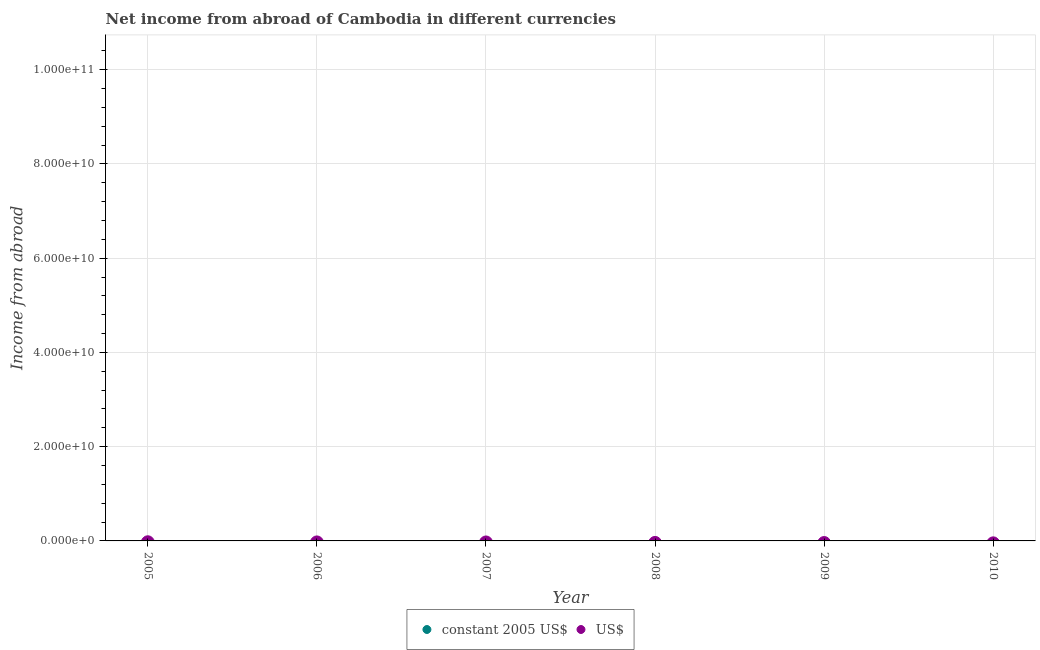How many different coloured dotlines are there?
Make the answer very short. 0. Is the number of dotlines equal to the number of legend labels?
Your answer should be compact. No. What is the total income from abroad in constant 2005 us$ in the graph?
Offer a very short reply. 0. What is the average income from abroad in us$ per year?
Your answer should be very brief. 0. Does the income from abroad in us$ monotonically increase over the years?
Provide a short and direct response. No. Is the income from abroad in us$ strictly greater than the income from abroad in constant 2005 us$ over the years?
Provide a short and direct response. Yes. Is the income from abroad in constant 2005 us$ strictly less than the income from abroad in us$ over the years?
Keep it short and to the point. Yes. How many dotlines are there?
Keep it short and to the point. 0. How many years are there in the graph?
Offer a very short reply. 6. What is the difference between two consecutive major ticks on the Y-axis?
Keep it short and to the point. 2.00e+1. Are the values on the major ticks of Y-axis written in scientific E-notation?
Ensure brevity in your answer.  Yes. Does the graph contain any zero values?
Your answer should be very brief. Yes. Where does the legend appear in the graph?
Ensure brevity in your answer.  Bottom center. How many legend labels are there?
Make the answer very short. 2. How are the legend labels stacked?
Your answer should be very brief. Horizontal. What is the title of the graph?
Offer a very short reply. Net income from abroad of Cambodia in different currencies. Does "Registered firms" appear as one of the legend labels in the graph?
Keep it short and to the point. No. What is the label or title of the X-axis?
Keep it short and to the point. Year. What is the label or title of the Y-axis?
Your answer should be compact. Income from abroad. What is the Income from abroad in constant 2005 US$ in 2006?
Offer a terse response. 0. What is the Income from abroad in US$ in 2007?
Ensure brevity in your answer.  0. What is the Income from abroad of constant 2005 US$ in 2008?
Offer a very short reply. 0. What is the Income from abroad of US$ in 2008?
Provide a succinct answer. 0. What is the Income from abroad in US$ in 2009?
Your response must be concise. 0. What is the Income from abroad in constant 2005 US$ in 2010?
Ensure brevity in your answer.  0. What is the total Income from abroad in constant 2005 US$ in the graph?
Give a very brief answer. 0. 